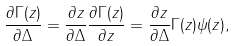Convert formula to latex. <formula><loc_0><loc_0><loc_500><loc_500>\frac { \partial \Gamma ( z ) } { \partial \Delta } = \frac { \partial z } { \partial \Delta } \frac { \partial \Gamma ( z ) } { \partial z } = \frac { \partial z } { \partial \Delta } \Gamma ( z ) \psi ( z ) ,</formula> 